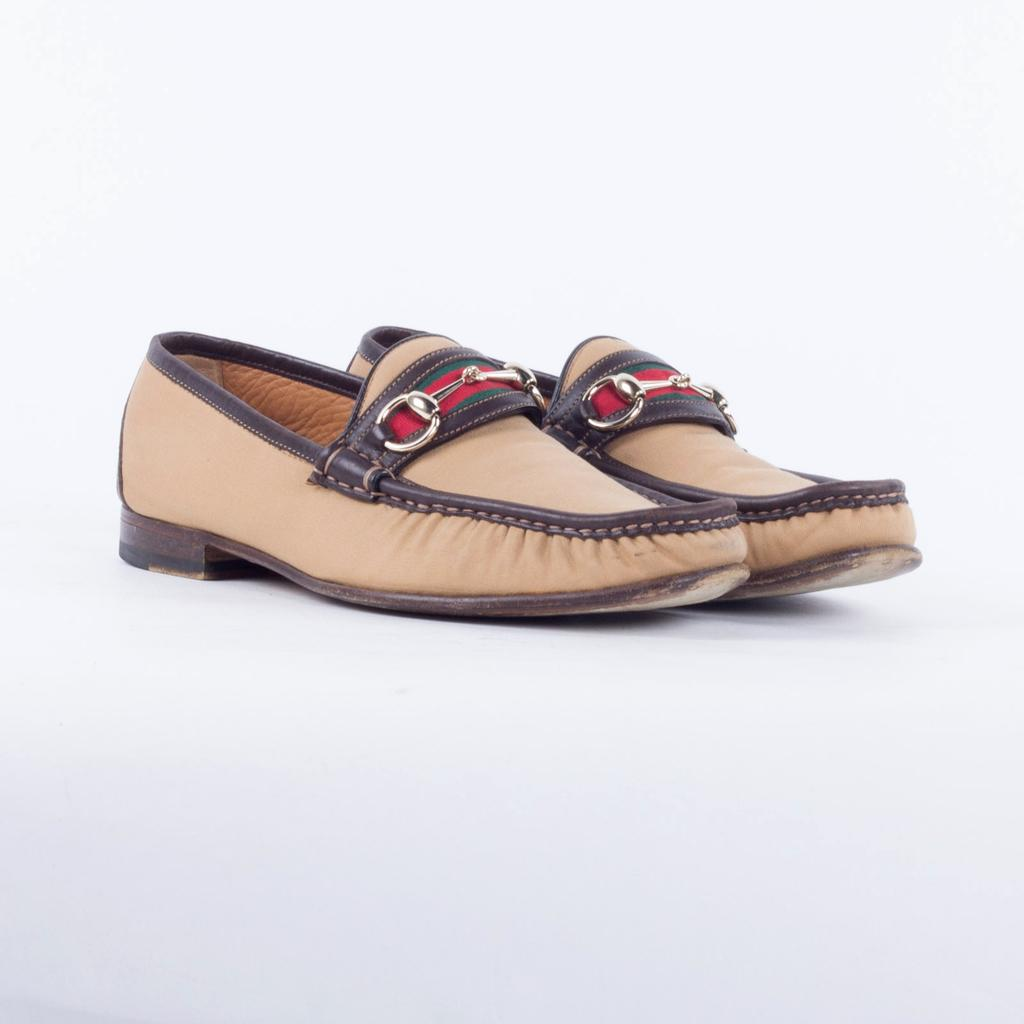What type of objects can be seen in the image? There are shoes in the image. What type of land can be seen in the image? There is no land visible in the image; it only features shoes. Can you tell me how many toads are present in the image? There are no toads present in the image; it only features shoes. 